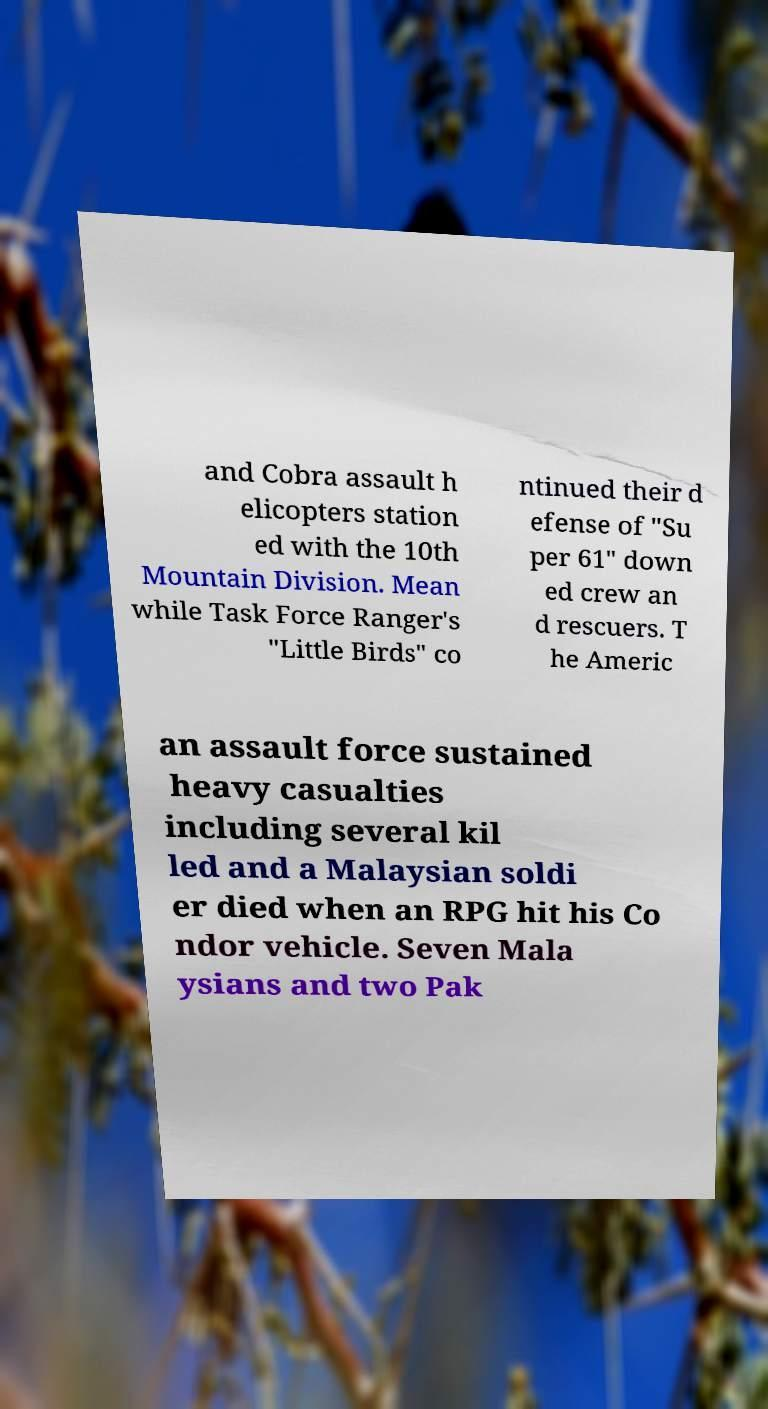What messages or text are displayed in this image? I need them in a readable, typed format. and Cobra assault h elicopters station ed with the 10th Mountain Division. Mean while Task Force Ranger's "Little Birds" co ntinued their d efense of "Su per 61" down ed crew an d rescuers. T he Americ an assault force sustained heavy casualties including several kil led and a Malaysian soldi er died when an RPG hit his Co ndor vehicle. Seven Mala ysians and two Pak 